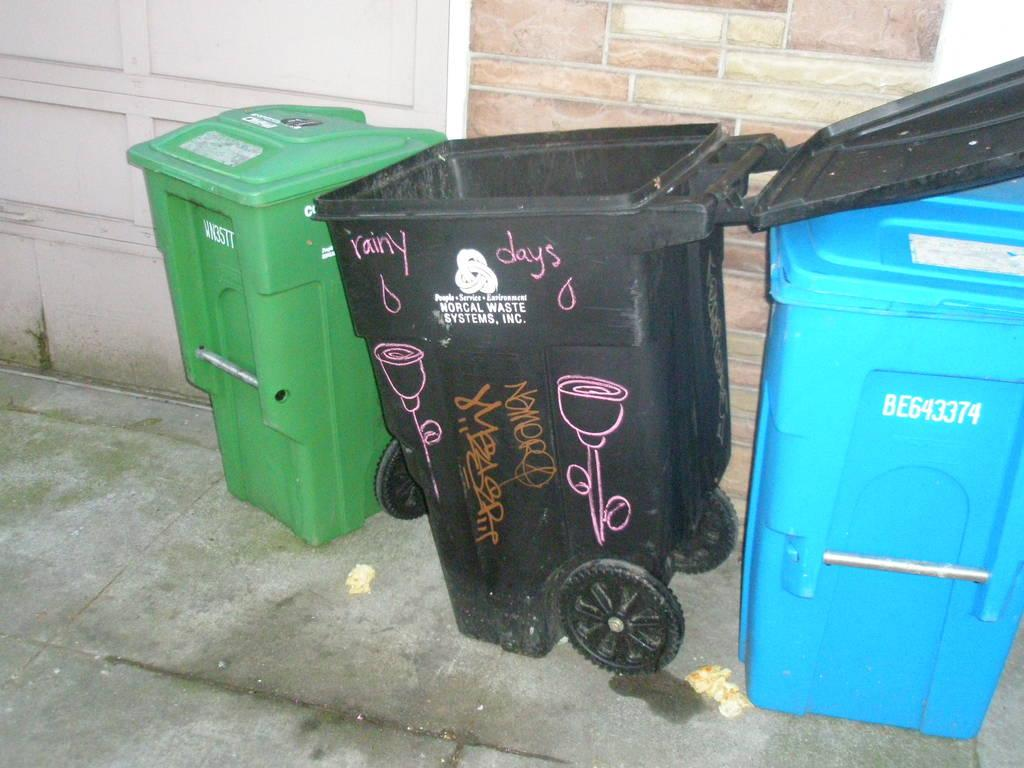<image>
Present a compact description of the photo's key features. The black bin has Norcal Waste Systems, Inc written on it. 